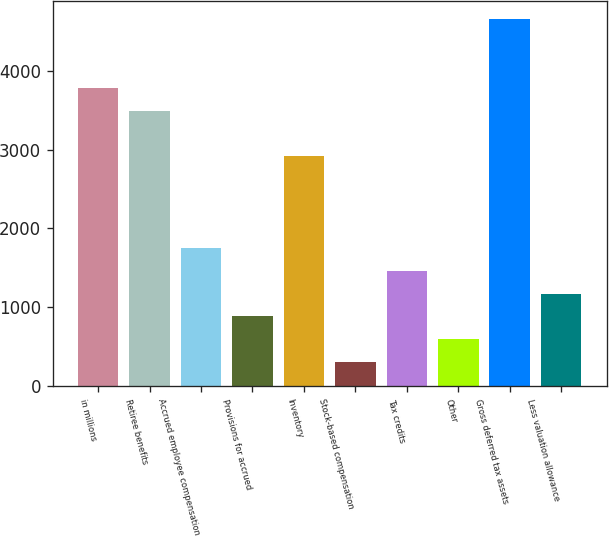Convert chart. <chart><loc_0><loc_0><loc_500><loc_500><bar_chart><fcel>in millions<fcel>Retiree benefits<fcel>Accrued employee compensation<fcel>Provisions for accrued<fcel>Inventory<fcel>Stock-based compensation<fcel>Tax credits<fcel>Other<fcel>Gross deferred tax assets<fcel>Less valuation allowance<nl><fcel>3782.7<fcel>3492.8<fcel>1753.4<fcel>883.7<fcel>2913<fcel>303.9<fcel>1463.5<fcel>593.8<fcel>4652.4<fcel>1173.6<nl></chart> 